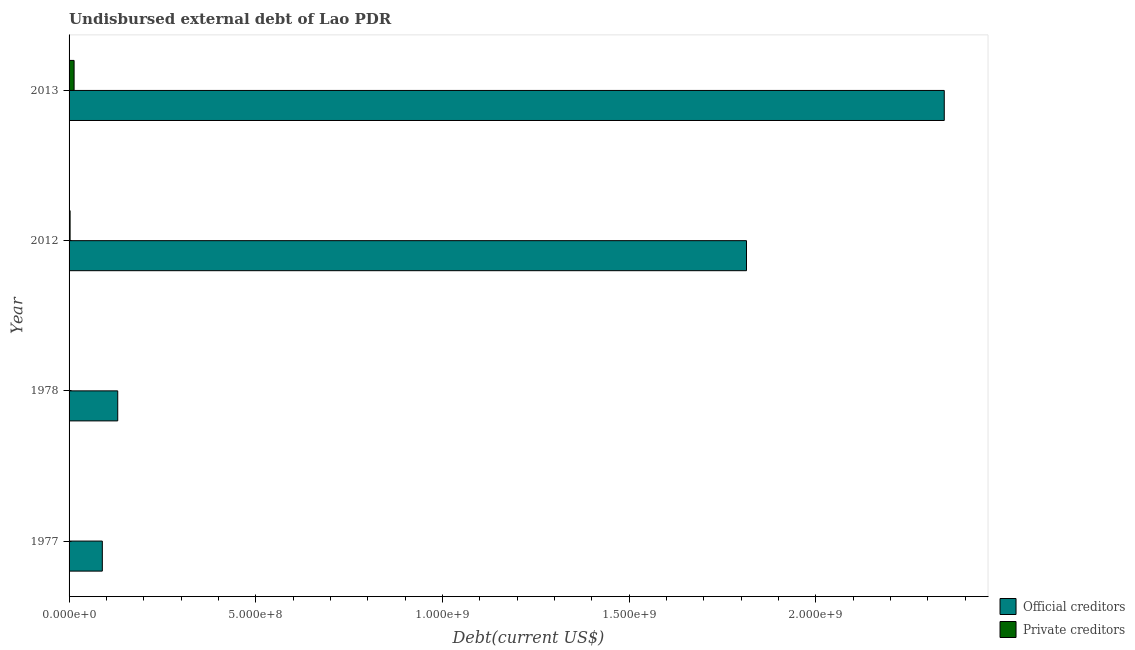How many groups of bars are there?
Your answer should be compact. 4. Are the number of bars on each tick of the Y-axis equal?
Your response must be concise. Yes. How many bars are there on the 1st tick from the top?
Give a very brief answer. 2. What is the label of the 4th group of bars from the top?
Make the answer very short. 1977. In how many cases, is the number of bars for a given year not equal to the number of legend labels?
Make the answer very short. 0. What is the undisbursed external debt of official creditors in 1977?
Offer a very short reply. 8.90e+07. Across all years, what is the maximum undisbursed external debt of private creditors?
Keep it short and to the point. 1.35e+07. Across all years, what is the minimum undisbursed external debt of private creditors?
Offer a very short reply. 1.69e+05. In which year was the undisbursed external debt of official creditors maximum?
Provide a succinct answer. 2013. What is the total undisbursed external debt of official creditors in the graph?
Keep it short and to the point. 4.38e+09. What is the difference between the undisbursed external debt of official creditors in 2012 and that in 2013?
Your response must be concise. -5.30e+08. What is the difference between the undisbursed external debt of official creditors in 2012 and the undisbursed external debt of private creditors in 1978?
Offer a very short reply. 1.81e+09. What is the average undisbursed external debt of official creditors per year?
Provide a short and direct response. 1.09e+09. In the year 2012, what is the difference between the undisbursed external debt of official creditors and undisbursed external debt of private creditors?
Provide a succinct answer. 1.81e+09. In how many years, is the undisbursed external debt of official creditors greater than 1800000000 US$?
Your answer should be very brief. 2. What is the ratio of the undisbursed external debt of private creditors in 1978 to that in 2013?
Offer a terse response. 0.01. What is the difference between the highest and the second highest undisbursed external debt of official creditors?
Give a very brief answer. 5.30e+08. What is the difference between the highest and the lowest undisbursed external debt of private creditors?
Offer a very short reply. 1.33e+07. Is the sum of the undisbursed external debt of private creditors in 1977 and 1978 greater than the maximum undisbursed external debt of official creditors across all years?
Ensure brevity in your answer.  No. What does the 1st bar from the top in 1978 represents?
Your response must be concise. Private creditors. What does the 1st bar from the bottom in 1978 represents?
Ensure brevity in your answer.  Official creditors. How many bars are there?
Make the answer very short. 8. What is the difference between two consecutive major ticks on the X-axis?
Keep it short and to the point. 5.00e+08. What is the title of the graph?
Ensure brevity in your answer.  Undisbursed external debt of Lao PDR. Does "IMF nonconcessional" appear as one of the legend labels in the graph?
Offer a very short reply. No. What is the label or title of the X-axis?
Provide a short and direct response. Debt(current US$). What is the label or title of the Y-axis?
Your answer should be compact. Year. What is the Debt(current US$) of Official creditors in 1977?
Your answer should be compact. 8.90e+07. What is the Debt(current US$) of Private creditors in 1977?
Your answer should be very brief. 4.46e+05. What is the Debt(current US$) of Official creditors in 1978?
Your answer should be compact. 1.30e+08. What is the Debt(current US$) of Private creditors in 1978?
Your answer should be very brief. 1.69e+05. What is the Debt(current US$) of Official creditors in 2012?
Your answer should be compact. 1.81e+09. What is the Debt(current US$) in Private creditors in 2012?
Your answer should be compact. 2.76e+06. What is the Debt(current US$) of Official creditors in 2013?
Your answer should be compact. 2.34e+09. What is the Debt(current US$) in Private creditors in 2013?
Give a very brief answer. 1.35e+07. Across all years, what is the maximum Debt(current US$) in Official creditors?
Give a very brief answer. 2.34e+09. Across all years, what is the maximum Debt(current US$) of Private creditors?
Offer a terse response. 1.35e+07. Across all years, what is the minimum Debt(current US$) in Official creditors?
Provide a short and direct response. 8.90e+07. Across all years, what is the minimum Debt(current US$) in Private creditors?
Offer a very short reply. 1.69e+05. What is the total Debt(current US$) of Official creditors in the graph?
Provide a succinct answer. 4.38e+09. What is the total Debt(current US$) in Private creditors in the graph?
Provide a short and direct response. 1.68e+07. What is the difference between the Debt(current US$) in Official creditors in 1977 and that in 1978?
Offer a terse response. -4.13e+07. What is the difference between the Debt(current US$) in Private creditors in 1977 and that in 1978?
Keep it short and to the point. 2.77e+05. What is the difference between the Debt(current US$) of Official creditors in 1977 and that in 2012?
Ensure brevity in your answer.  -1.73e+09. What is the difference between the Debt(current US$) in Private creditors in 1977 and that in 2012?
Keep it short and to the point. -2.31e+06. What is the difference between the Debt(current US$) of Official creditors in 1977 and that in 2013?
Provide a short and direct response. -2.25e+09. What is the difference between the Debt(current US$) in Private creditors in 1977 and that in 2013?
Ensure brevity in your answer.  -1.30e+07. What is the difference between the Debt(current US$) in Official creditors in 1978 and that in 2012?
Your answer should be very brief. -1.68e+09. What is the difference between the Debt(current US$) of Private creditors in 1978 and that in 2012?
Provide a short and direct response. -2.59e+06. What is the difference between the Debt(current US$) in Official creditors in 1978 and that in 2013?
Your answer should be compact. -2.21e+09. What is the difference between the Debt(current US$) in Private creditors in 1978 and that in 2013?
Make the answer very short. -1.33e+07. What is the difference between the Debt(current US$) in Official creditors in 2012 and that in 2013?
Make the answer very short. -5.30e+08. What is the difference between the Debt(current US$) in Private creditors in 2012 and that in 2013?
Your answer should be very brief. -1.07e+07. What is the difference between the Debt(current US$) of Official creditors in 1977 and the Debt(current US$) of Private creditors in 1978?
Give a very brief answer. 8.89e+07. What is the difference between the Debt(current US$) in Official creditors in 1977 and the Debt(current US$) in Private creditors in 2012?
Keep it short and to the point. 8.63e+07. What is the difference between the Debt(current US$) in Official creditors in 1977 and the Debt(current US$) in Private creditors in 2013?
Make the answer very short. 7.56e+07. What is the difference between the Debt(current US$) of Official creditors in 1978 and the Debt(current US$) of Private creditors in 2012?
Keep it short and to the point. 1.28e+08. What is the difference between the Debt(current US$) in Official creditors in 1978 and the Debt(current US$) in Private creditors in 2013?
Give a very brief answer. 1.17e+08. What is the difference between the Debt(current US$) in Official creditors in 2012 and the Debt(current US$) in Private creditors in 2013?
Provide a succinct answer. 1.80e+09. What is the average Debt(current US$) of Official creditors per year?
Offer a terse response. 1.09e+09. What is the average Debt(current US$) in Private creditors per year?
Make the answer very short. 4.21e+06. In the year 1977, what is the difference between the Debt(current US$) of Official creditors and Debt(current US$) of Private creditors?
Your answer should be compact. 8.86e+07. In the year 1978, what is the difference between the Debt(current US$) of Official creditors and Debt(current US$) of Private creditors?
Offer a terse response. 1.30e+08. In the year 2012, what is the difference between the Debt(current US$) in Official creditors and Debt(current US$) in Private creditors?
Your answer should be very brief. 1.81e+09. In the year 2013, what is the difference between the Debt(current US$) in Official creditors and Debt(current US$) in Private creditors?
Ensure brevity in your answer.  2.33e+09. What is the ratio of the Debt(current US$) in Official creditors in 1977 to that in 1978?
Make the answer very short. 0.68. What is the ratio of the Debt(current US$) in Private creditors in 1977 to that in 1978?
Your response must be concise. 2.64. What is the ratio of the Debt(current US$) of Official creditors in 1977 to that in 2012?
Your answer should be very brief. 0.05. What is the ratio of the Debt(current US$) in Private creditors in 1977 to that in 2012?
Make the answer very short. 0.16. What is the ratio of the Debt(current US$) in Official creditors in 1977 to that in 2013?
Provide a succinct answer. 0.04. What is the ratio of the Debt(current US$) in Private creditors in 1977 to that in 2013?
Make the answer very short. 0.03. What is the ratio of the Debt(current US$) of Official creditors in 1978 to that in 2012?
Give a very brief answer. 0.07. What is the ratio of the Debt(current US$) in Private creditors in 1978 to that in 2012?
Offer a terse response. 0.06. What is the ratio of the Debt(current US$) in Official creditors in 1978 to that in 2013?
Provide a short and direct response. 0.06. What is the ratio of the Debt(current US$) in Private creditors in 1978 to that in 2013?
Your response must be concise. 0.01. What is the ratio of the Debt(current US$) in Official creditors in 2012 to that in 2013?
Keep it short and to the point. 0.77. What is the ratio of the Debt(current US$) in Private creditors in 2012 to that in 2013?
Offer a very short reply. 0.21. What is the difference between the highest and the second highest Debt(current US$) in Official creditors?
Offer a terse response. 5.30e+08. What is the difference between the highest and the second highest Debt(current US$) of Private creditors?
Provide a short and direct response. 1.07e+07. What is the difference between the highest and the lowest Debt(current US$) of Official creditors?
Your response must be concise. 2.25e+09. What is the difference between the highest and the lowest Debt(current US$) in Private creditors?
Provide a succinct answer. 1.33e+07. 